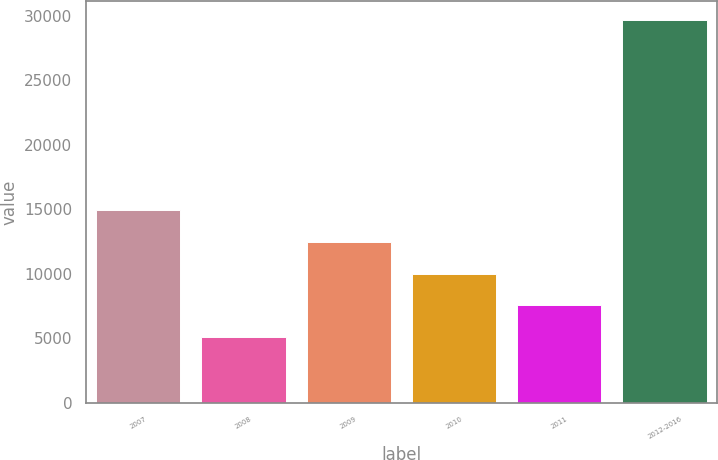Convert chart to OTSL. <chart><loc_0><loc_0><loc_500><loc_500><bar_chart><fcel>2007<fcel>2008<fcel>2009<fcel>2010<fcel>2011<fcel>2012-2016<nl><fcel>14916.6<fcel>5091<fcel>12460.2<fcel>10003.8<fcel>7547.4<fcel>29655<nl></chart> 